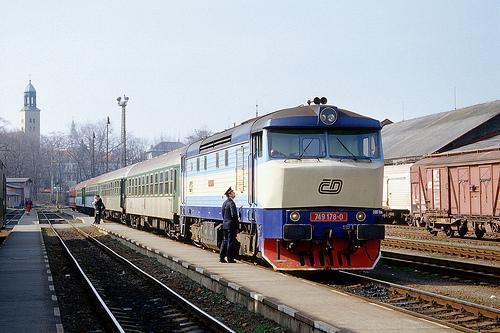How many horns are on the front of the train?
Give a very brief answer. 2. How many of the buildings have towers?
Give a very brief answer. 2. How many people are in the picture?
Give a very brief answer. 2. 